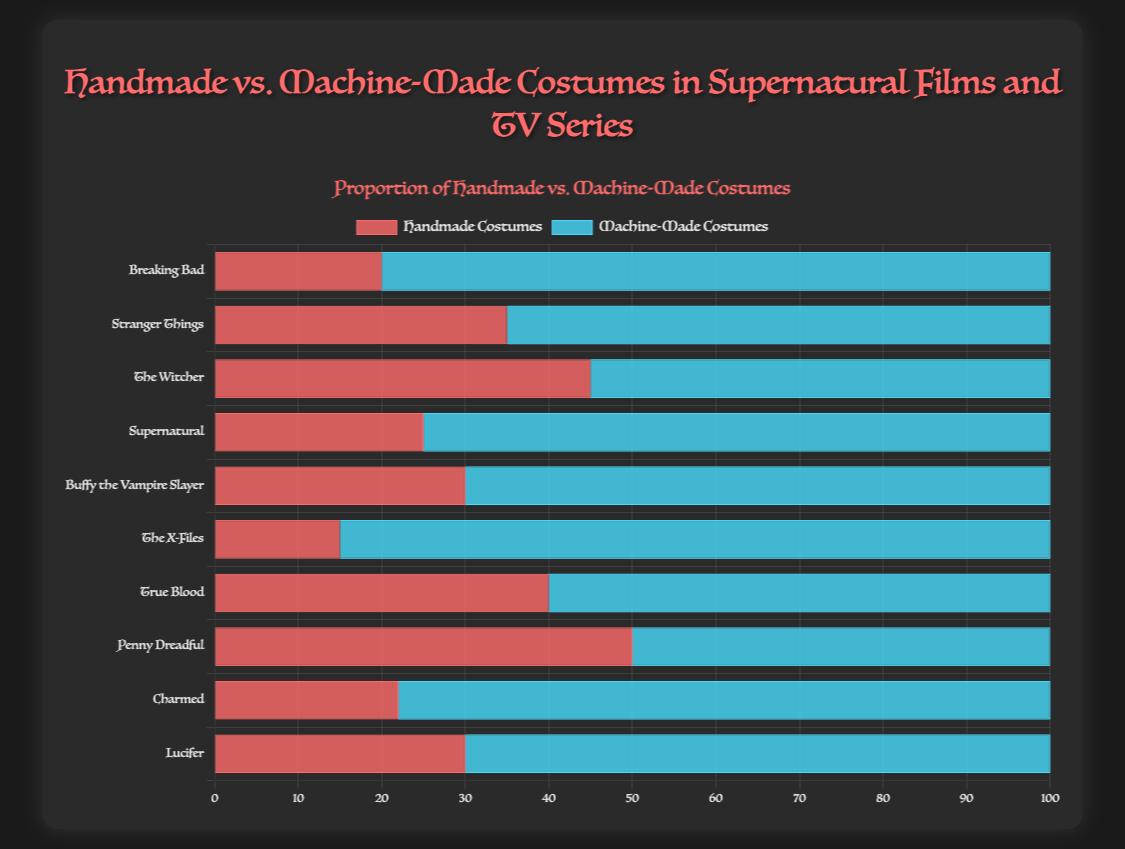Which show has the highest number of handmade costumes? By examining the length of the red bars, it appears that "Penny Dreadful" has the highest number of handmade costumes at 50.
Answer: Penny Dreadful What is the total number of handmade costumes for "Breaking Bad" and "Stranger Things"? Adding the values for handmade costumes in "Breaking Bad" (20) and "Stranger Things" (35) yields 20 + 35 = 55.
Answer: 55 How many more machine-made costumes are there in "Supernatural" compared to handmade costumes? The machine-made costumes for "Supernatural" are 75, while the handmade ones are 25. The difference is 75 - 25 = 50.
Answer: 50 Which show has the smallest proportion of handmade costumes? "The X-Files" has the smallest number of handmade costumes at 15, as indicated by the shortest red bar.
Answer: The X-Files Are there any shows where the number of handmade and machine-made costumes are equal? The bar lengths for "Penny Dreadful" indicate that both handmade and machine-made costumes are 50.
Answer: Penny Dreadful What is the average number of handmade costumes for all shown series? The handmade costumes totals are: 20, 35, 45, 25, 30, 15, 40, 50, 22, 30. Summing these gives 312. Dividing by 10 (the number of series) results in an average of 31.2.
Answer: 31.2 Which show has the largest difference in proportion between handmade and machine-made costumes? Comparing the differences between machine-made and handmade counts for each series, "Breaking Bad" has the largest difference with a difference of 80 - 20 = 60.
Answer: Breaking Bad Do more series have a higher proportion of handmade or machine-made costumes? By counting the number of series with more handmade vs. machine-made costumes, only "Penny Dreadful" has more handmade. This indicates that more series favor machine-made costumes.
Answer: Machine-Made What is the total number of costumes (both handmade and machine-made) for "True Blood"? Adding the values for "True Blood" handmade (40) and machine-made (60), the total is 40 + 60 = 100.
Answer: 100 Which show features the closest number of handmade and machine-made costumes, excluding "Penny Dreadful"? Comparing the differences: "The Witcher" with 10 apart (45 handmade, 55 machine-made) has the closest number after "Penny Dreadful" which has an equal number.
Answer: The Witcher 